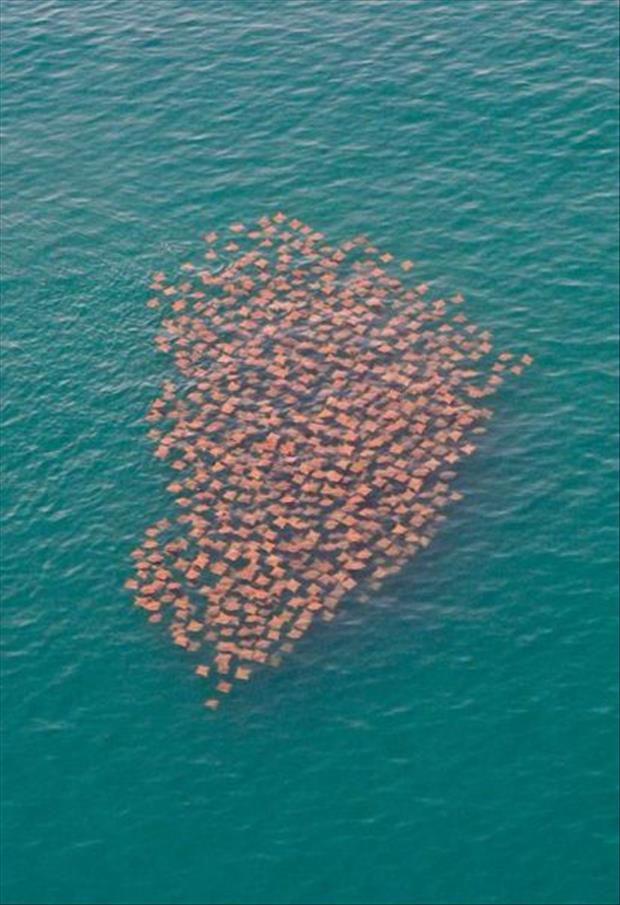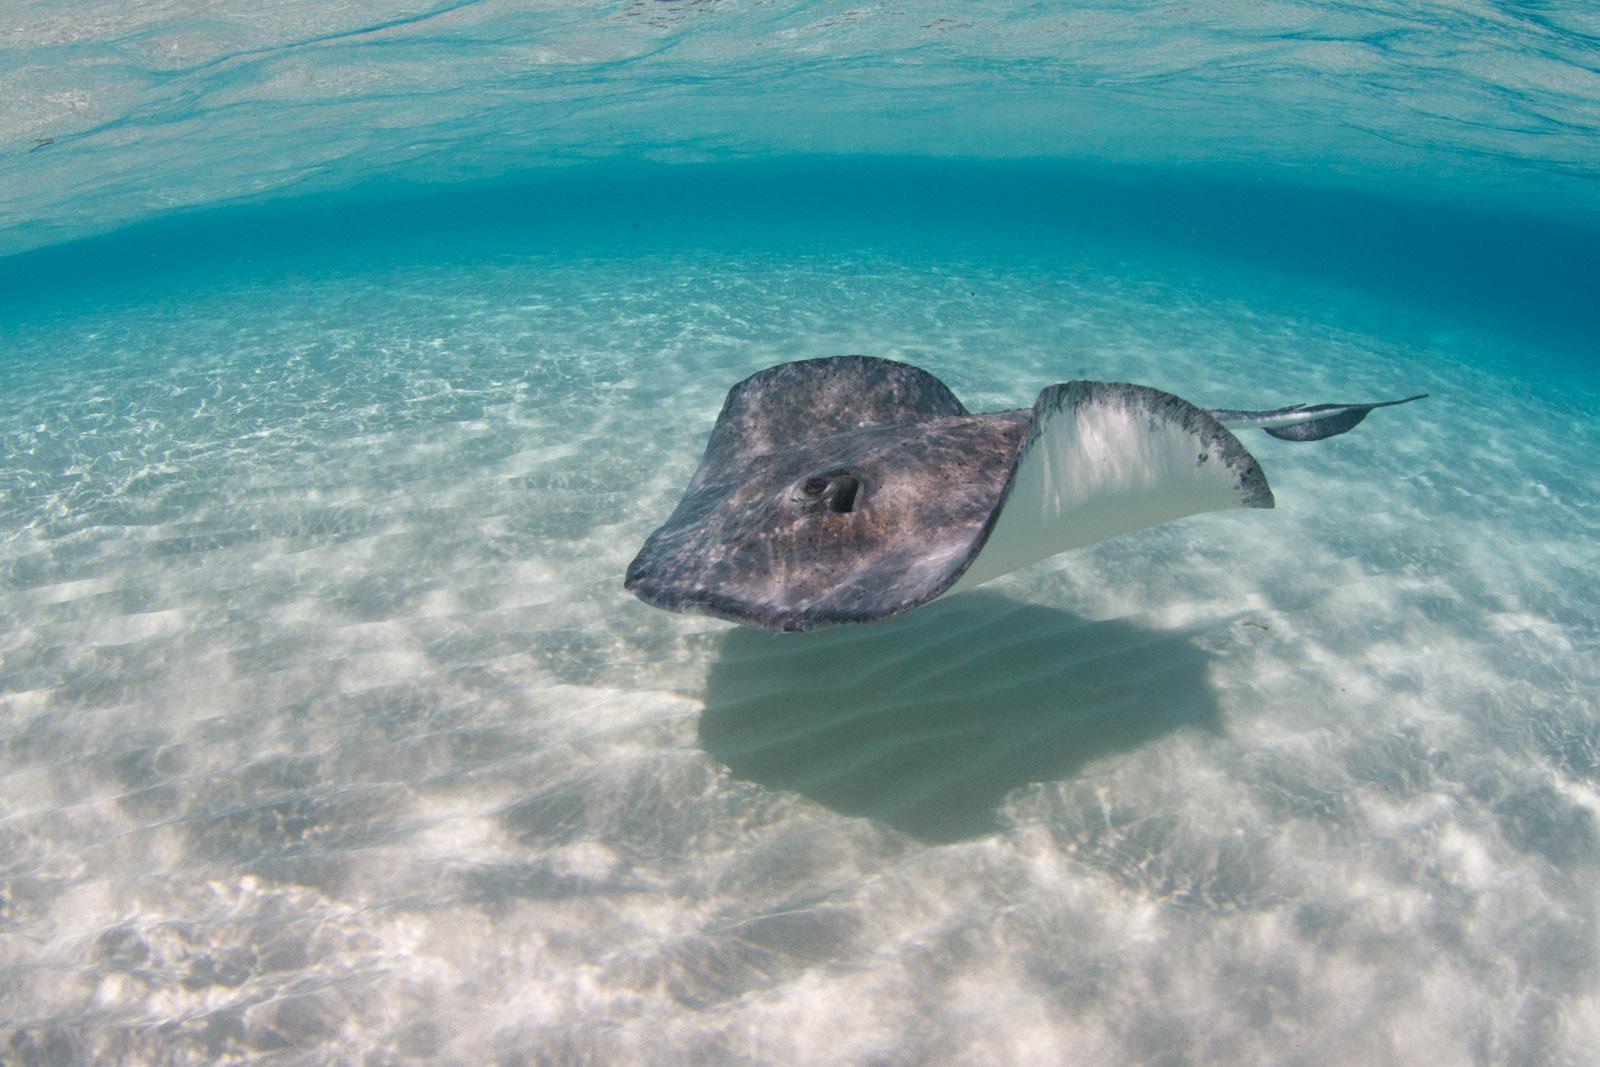The first image is the image on the left, the second image is the image on the right. Assess this claim about the two images: "At least one human is in the ocean with the fish in one of the images.". Correct or not? Answer yes or no. No. The first image is the image on the left, the second image is the image on the right. Examine the images to the left and right. Is the description "In one image, at least one person is in the water interacting with a stingray, and a snorkel is visible." accurate? Answer yes or no. No. 